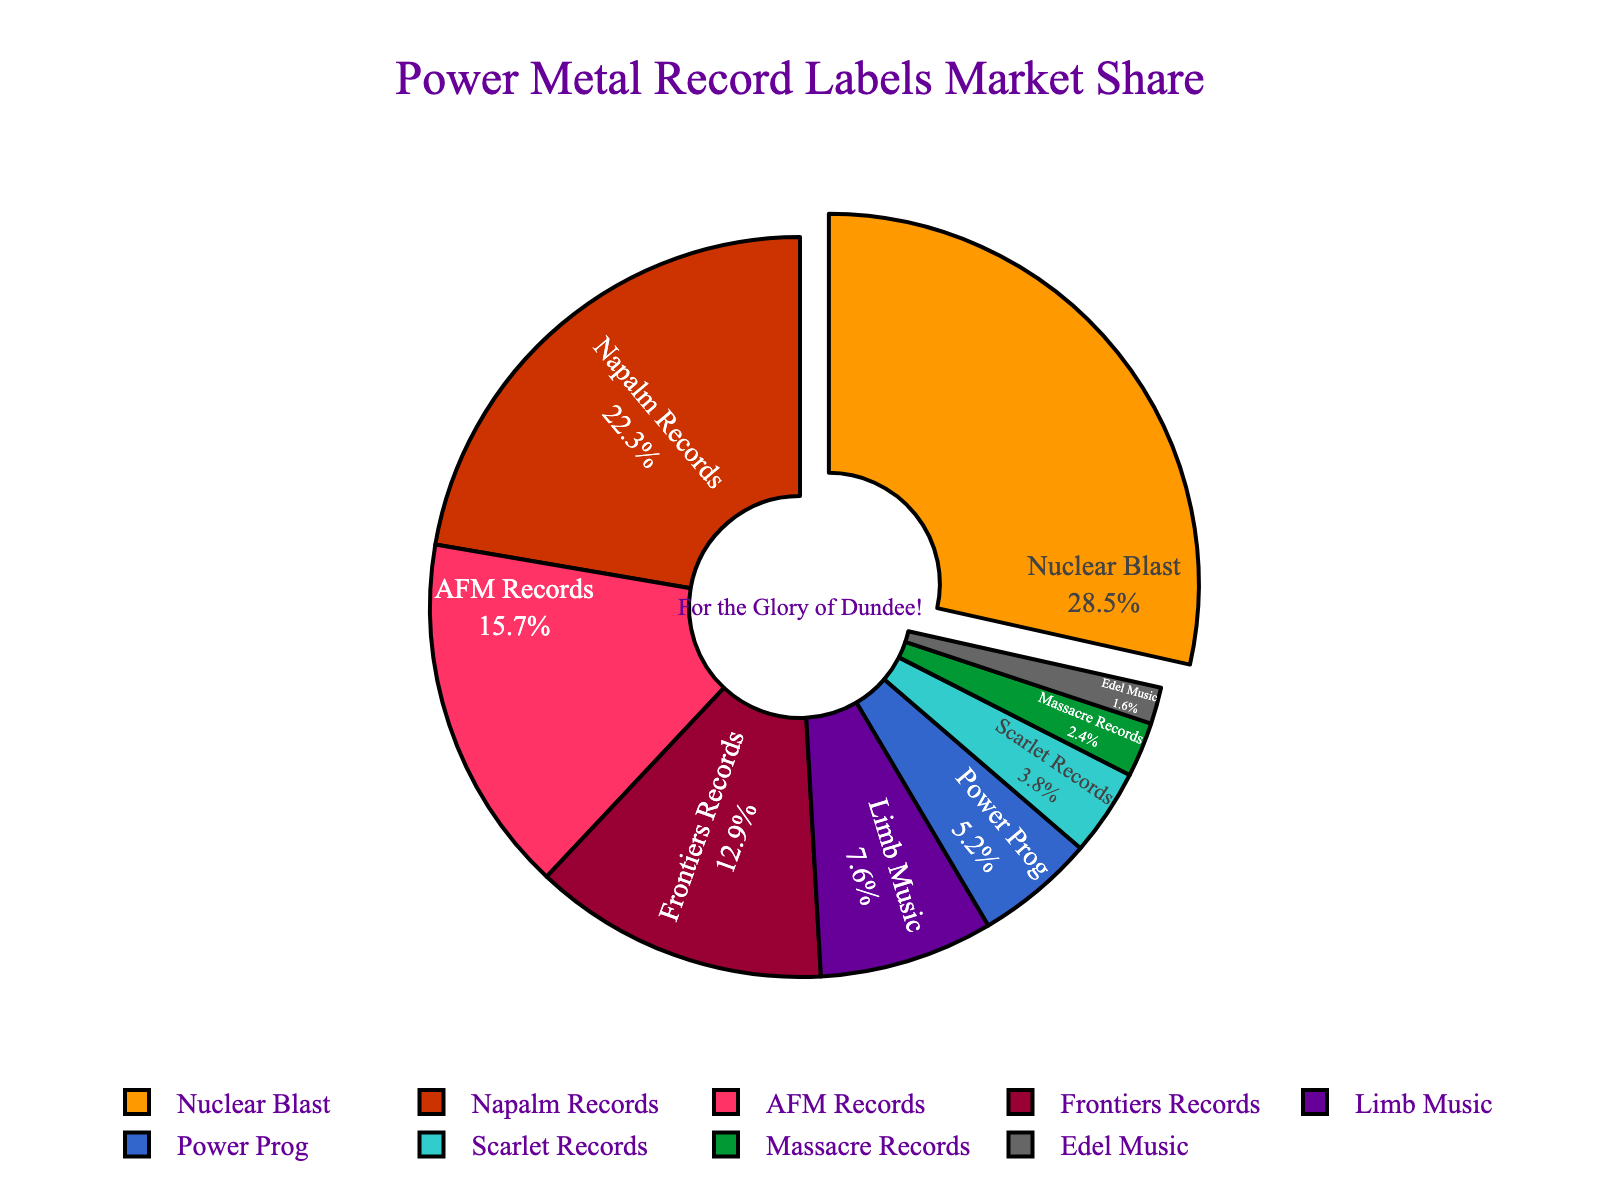What's the market share of the label with the highest share? The label with the highest market share is Nuclear Blast. The figure shows Nuclear Blast occupying the largest portion of the chart at 28.5%.
Answer: 28.5% How much more market share does Nuclear Blast have compared to Napalm Records? Nuclear Blast has a market share of 28.5%, while Napalm Records has a 22.3% share. The difference is 28.5 - 22.3 = 6.2%.
Answer: 6.2% Which label has the smallest market share? The label with the smallest market share is Edel Music, as it occupies the smallest segment of the pie at 1.6%.
Answer: Edel Music What is the combined market share of AFM Records and Frontiers Records? AFM Records has a market share of 15.7% and Frontiers Records has a market share of 12.9%. The combined share is 15.7 + 12.9 = 28.6%.
Answer: 28.6% Which record labels have a market share greater than 10%? The labels with a market share greater than 10% are Nuclear Blast (28.5%), Napalm Records (22.3%), AFM Records (15.7%), and Frontiers Records (12.9%).
Answer: Nuclear Blast, Napalm Records, AFM Records, Frontiers Records What color represents Scarlet Records in the chart? The color representing Scarlet Records in the chart is a shade of red.
Answer: red How many labels have a market share lower than 10%? The labels with market share lower than 10% are Limb Music (7.6%), Power Prog (5.2%), Scarlet Records (3.8%), Massacre Records (2.4%), and Edel Music (1.6%). Counting these, there are 5 labels.
Answer: 5 What is the sum of the market shares of the three largest labels? The three largest labels are Nuclear Blast (28.5%), Napalm Records (22.3%), and AFM Records (15.7%). Summing these: 28.5 + 22.3 + 15.7 = 66.5%.
Answer: 66.5% Compare the market share of Power Prog to that of Limb Music. Which is greater and by how much? Power Prog has a market share of 5.2%, and Limb Music has a market share of 7.6%. Limb Music has a greater share. The difference is 7.6 - 5.2 = 2.4%.
Answer: Limb Music by 2.4% If Nuclear Blast and Napalm Records combined their shares, what fraction of the total market would they occupy? Nuclear Blast has a 28.5% share, and Napalm Records has a 22.3% share. Combined, they would have 28.5 + 22.3 = 50.8%. Converted to a fraction, 50.8% is 50.8/100 = 0.508, or roughly 51/100.
Answer: 0.508 